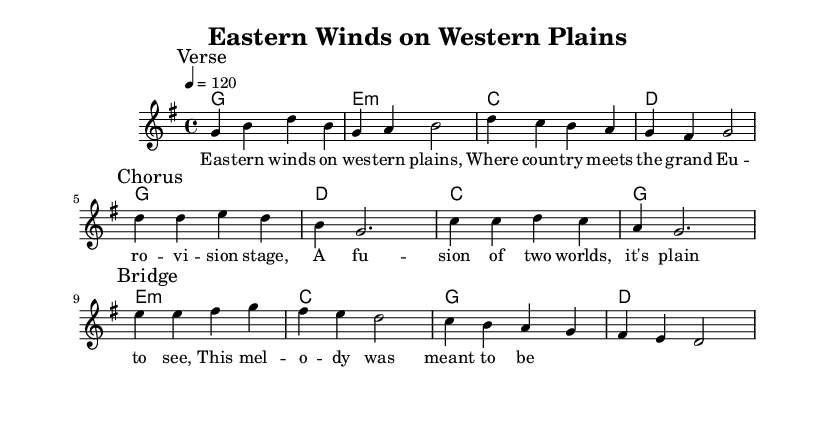What is the key signature of this music? The key signature is G major, indicated by one sharp (F#). It can be found at the beginning of the staff where the key signature is shown.
Answer: G major What is the time signature of this music? The time signature is 4/4, which is indicated next to the key signature at the beginning of the score. This means there are four beats in each measure.
Answer: 4/4 What is the tempo marking of this piece? The tempo marking is shown as "4 = 120," indicating that the piece should be played at 120 beats per minute. This is typically found near the top of the score.
Answer: 120 How many measures are in the chorus section? The chorus section contains four measures, as indicated by the measures counted within the section marked "Chorus." Each section is separated by a break in the notation.
Answer: Four What is the first note of the bridge? The first note of the bridge is E, as indicated by the melody line starting on E in the section marked "Bridge." It's clearly marked after the break.
Answer: E How does the harmony change in the second line of the song? The harmony in the second line changes from E minor to C and then to D, as shown in the chord changes indicating the harmonic progression for that section.
Answer: E minor to C to D What lyrical theme is presented in the song? The song presents a theme focusing on the fusion of country music with the Eurovision style, symbolized by the lyrics discussing "eastern winds" and "the grand Eurovision stage." This theme reflects an intersection of cultural influences.
Answer: Fusion of country and Eurovision 